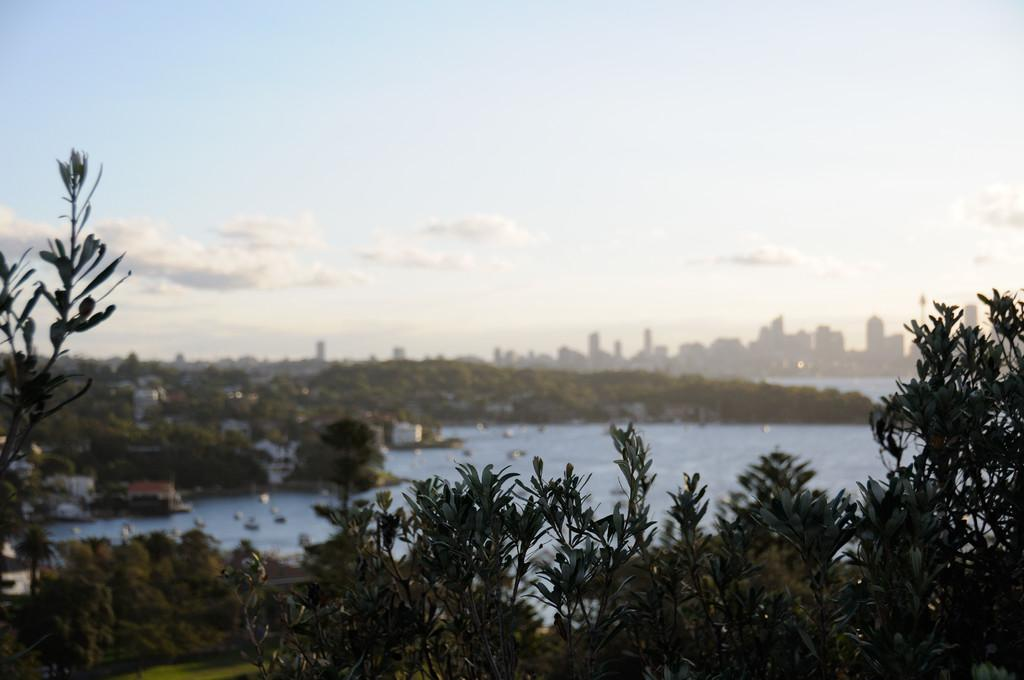What natural element is visible in the image? Water is visible in the image. What type of vegetation can be seen in the image? There are plants and trees in the image. What type of man-made structures are present in the image? There are buildings in the image. What part of the natural environment is visible in the image? The sky is visible in the background of the image. What type of lettuce is growing along the border in the image? There is no lettuce or border present in the image. What is the interest rate for the loan depicted in the image? There is no loan or interest rate depicted in the image. 